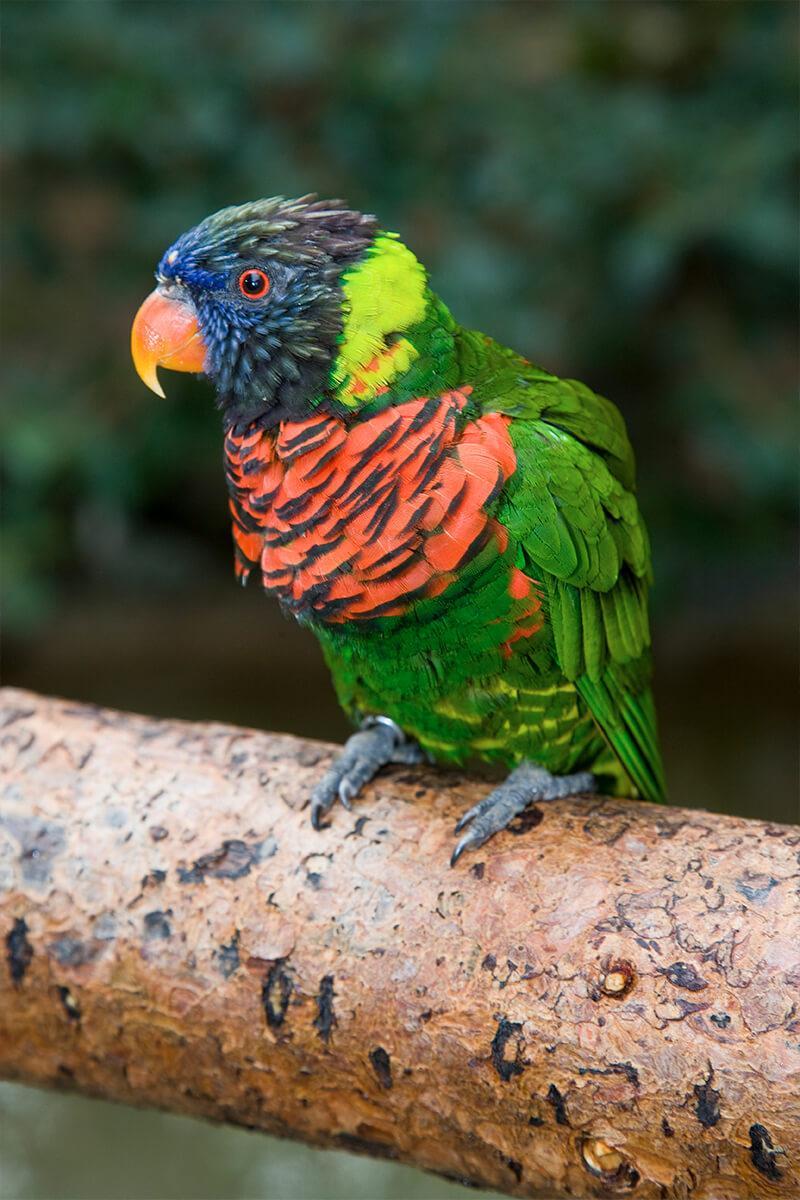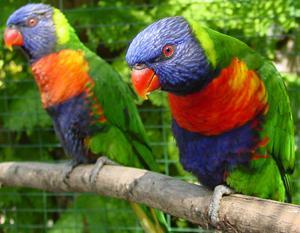The first image is the image on the left, the second image is the image on the right. Examine the images to the left and right. Is the description "All of the images contain only one parrot." accurate? Answer yes or no. No. 